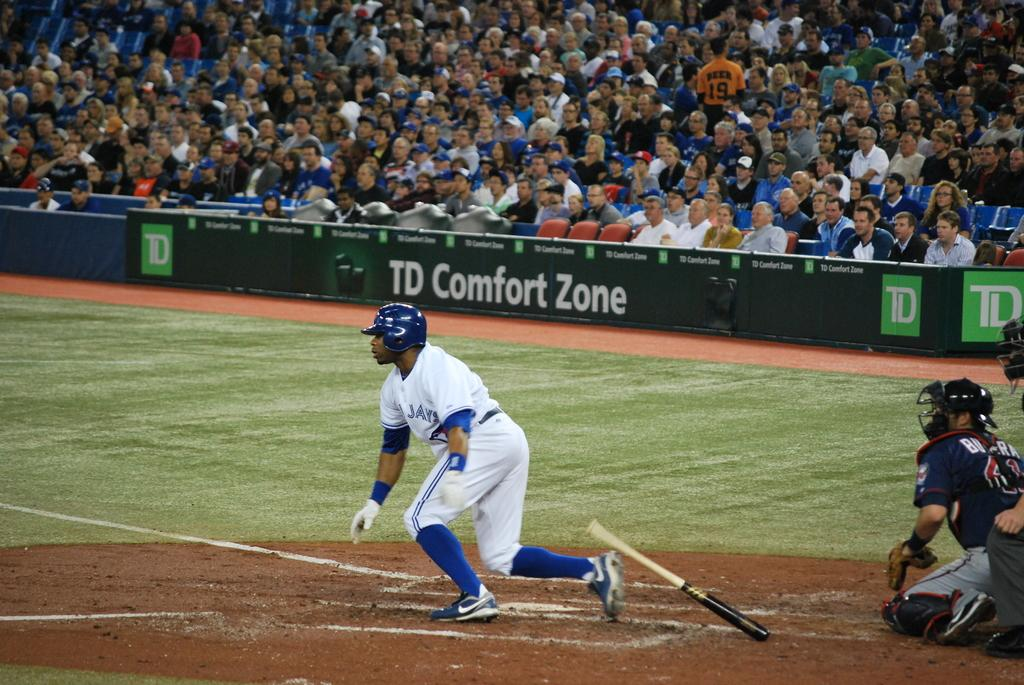<image>
Summarize the visual content of the image. a man hitting a ball with a TD Comfort Zone ad in the background 